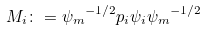Convert formula to latex. <formula><loc_0><loc_0><loc_500><loc_500>M _ { i } \colon = { { \psi _ { m } } ^ { - 1 / 2 } } p _ { i } \psi _ { i } { { \psi _ { m } } ^ { - 1 / 2 } }</formula> 